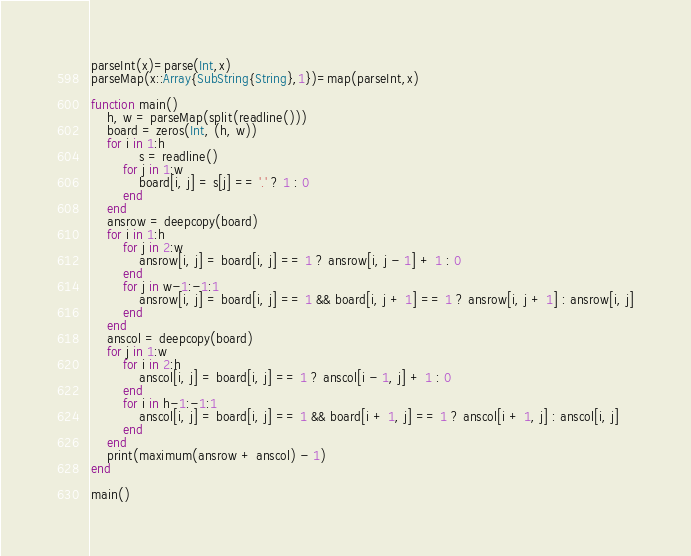<code> <loc_0><loc_0><loc_500><loc_500><_Julia_>parseInt(x)=parse(Int,x)
parseMap(x::Array{SubString{String},1})=map(parseInt,x)

function main()
    h, w = parseMap(split(readline()))
    board = zeros(Int, (h, w))
    for i in 1:h
            s = readline()
        for j in 1:w
            board[i, j] = s[j] == '.' ? 1 : 0
        end
    end
    ansrow = deepcopy(board)
    for i in 1:h
        for j in 2:w
            ansrow[i, j] = board[i, j] == 1 ? ansrow[i, j - 1] + 1 : 0
        end
        for j in w-1:-1:1
            ansrow[i, j] = board[i, j] == 1 && board[i, j + 1] == 1 ? ansrow[i, j + 1] : ansrow[i, j]
        end
    end
    anscol = deepcopy(board)
    for j in 1:w
        for i in 2:h
            anscol[i, j] = board[i, j] == 1 ? anscol[i - 1, j] + 1 : 0
        end
        for i in h-1:-1:1
            anscol[i, j] = board[i, j] == 1 && board[i + 1, j] == 1 ? anscol[i + 1, j] : anscol[i, j]
        end
    end
    print(maximum(ansrow + anscol) - 1)
end

main()
</code> 